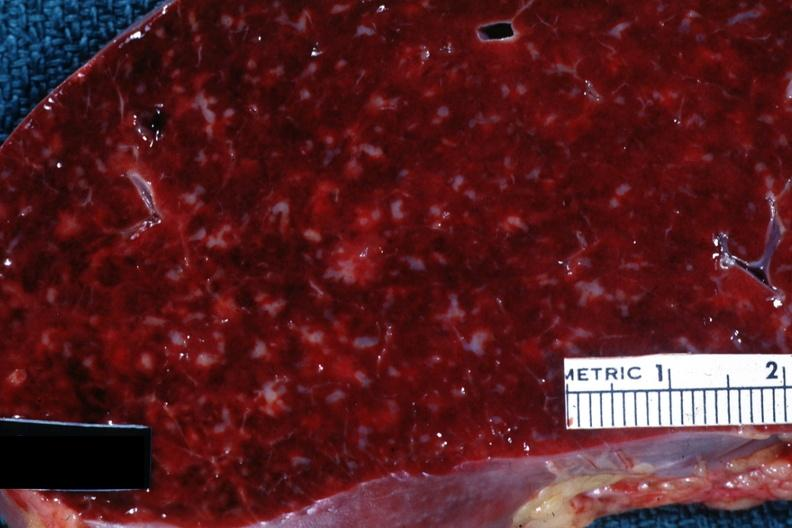what is present?
Answer the question using a single word or phrase. Chronic lymphocytic leukemia 